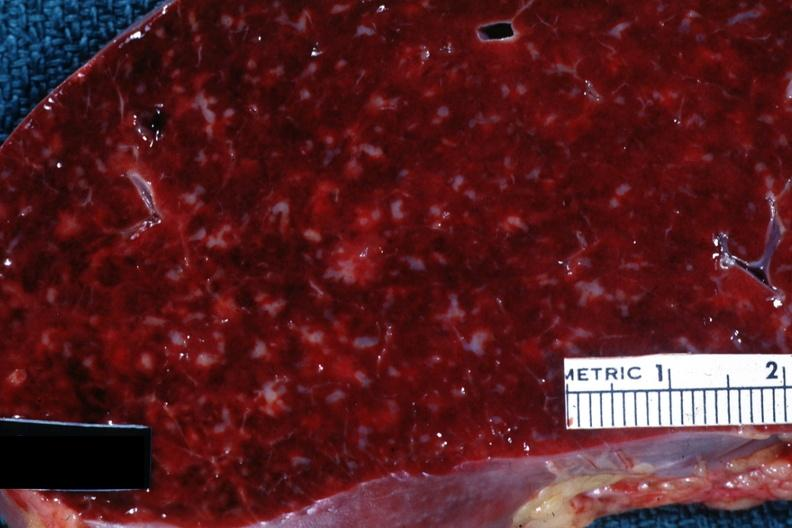what is present?
Answer the question using a single word or phrase. Chronic lymphocytic leukemia 